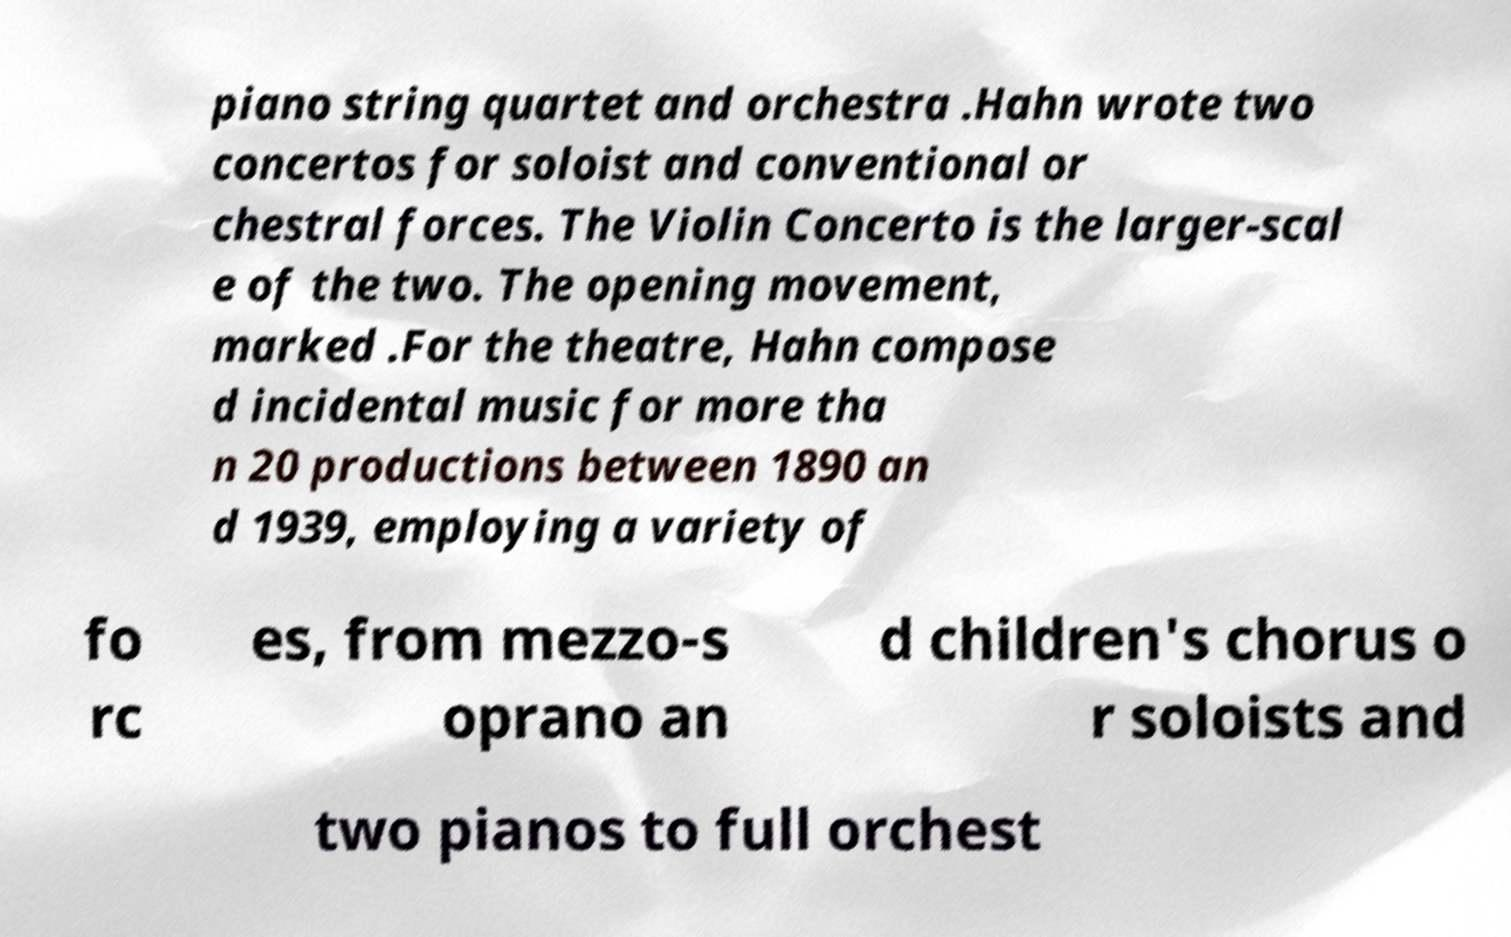Could you extract and type out the text from this image? piano string quartet and orchestra .Hahn wrote two concertos for soloist and conventional or chestral forces. The Violin Concerto is the larger-scal e of the two. The opening movement, marked .For the theatre, Hahn compose d incidental music for more tha n 20 productions between 1890 an d 1939, employing a variety of fo rc es, from mezzo-s oprano an d children's chorus o r soloists and two pianos to full orchest 